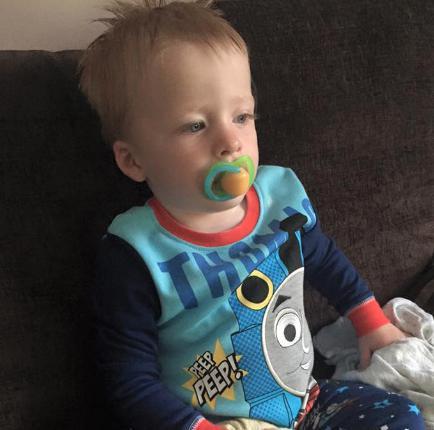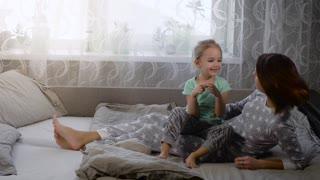The first image is the image on the left, the second image is the image on the right. Considering the images on both sides, is "One image has an adult with a kid in their lap." valid? Answer yes or no. Yes. The first image is the image on the left, the second image is the image on the right. For the images displayed, is the sentence "One of the images has both a boy and a girl." factually correct? Answer yes or no. No. 